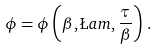<formula> <loc_0><loc_0><loc_500><loc_500>\phi = \phi \left ( \beta , \L a m , \frac { \tau } { \beta } \right ) \, .</formula> 